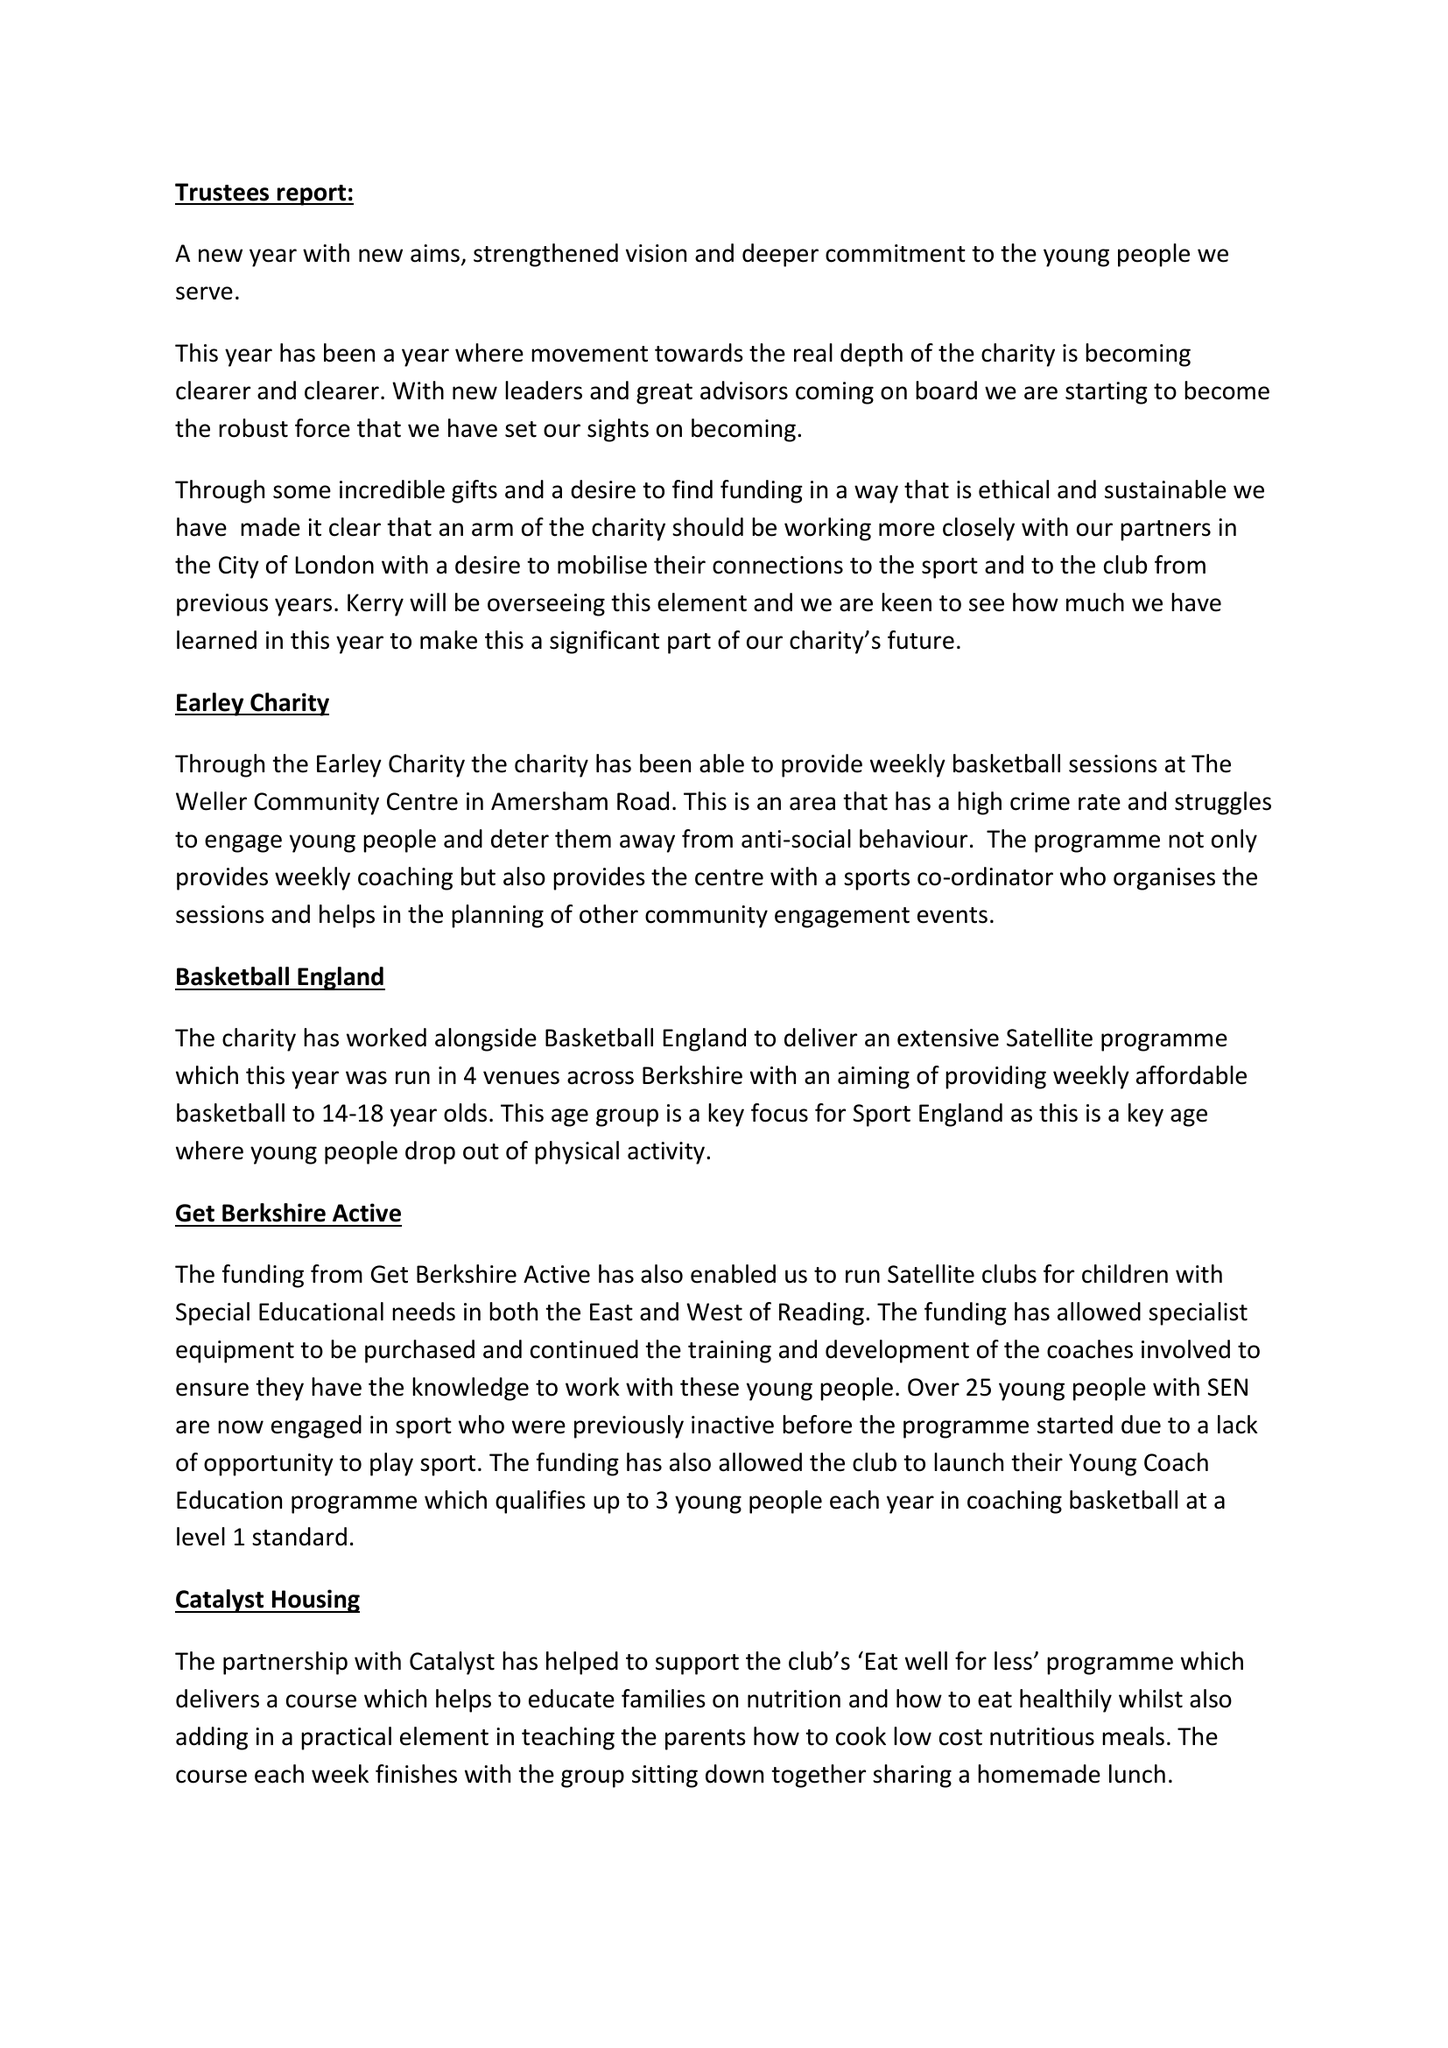What is the value for the charity_number?
Answer the question using a single word or phrase. 1148764 